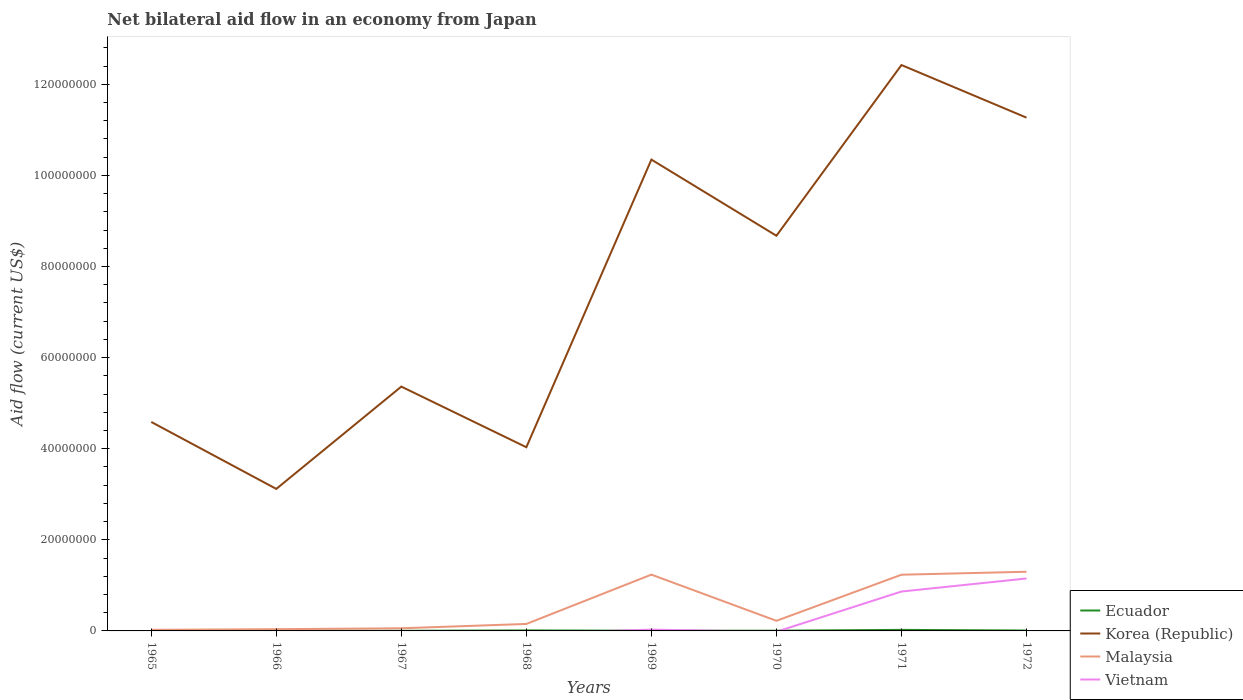How many different coloured lines are there?
Keep it short and to the point. 4. Does the line corresponding to Malaysia intersect with the line corresponding to Korea (Republic)?
Offer a very short reply. No. Is the number of lines equal to the number of legend labels?
Give a very brief answer. No. Across all years, what is the maximum net bilateral aid flow in Malaysia?
Offer a very short reply. 2.40e+05. What is the difference between the highest and the second highest net bilateral aid flow in Ecuador?
Offer a terse response. 2.10e+05. What is the difference between the highest and the lowest net bilateral aid flow in Ecuador?
Provide a succinct answer. 3. What is the difference between two consecutive major ticks on the Y-axis?
Ensure brevity in your answer.  2.00e+07. Are the values on the major ticks of Y-axis written in scientific E-notation?
Provide a succinct answer. No. Does the graph contain grids?
Your answer should be compact. No. How many legend labels are there?
Offer a very short reply. 4. How are the legend labels stacked?
Your response must be concise. Vertical. What is the title of the graph?
Make the answer very short. Net bilateral aid flow in an economy from Japan. What is the Aid flow (current US$) of Korea (Republic) in 1965?
Make the answer very short. 4.59e+07. What is the Aid flow (current US$) of Malaysia in 1965?
Provide a succinct answer. 2.40e+05. What is the Aid flow (current US$) in Ecuador in 1966?
Provide a succinct answer. 6.00e+04. What is the Aid flow (current US$) in Korea (Republic) in 1966?
Keep it short and to the point. 3.12e+07. What is the Aid flow (current US$) of Malaysia in 1966?
Offer a terse response. 3.80e+05. What is the Aid flow (current US$) of Korea (Republic) in 1967?
Your answer should be very brief. 5.36e+07. What is the Aid flow (current US$) in Malaysia in 1967?
Offer a very short reply. 5.80e+05. What is the Aid flow (current US$) of Korea (Republic) in 1968?
Offer a terse response. 4.03e+07. What is the Aid flow (current US$) in Malaysia in 1968?
Ensure brevity in your answer.  1.53e+06. What is the Aid flow (current US$) of Vietnam in 1968?
Your answer should be very brief. 0. What is the Aid flow (current US$) of Korea (Republic) in 1969?
Offer a very short reply. 1.03e+08. What is the Aid flow (current US$) of Malaysia in 1969?
Offer a very short reply. 1.24e+07. What is the Aid flow (current US$) of Vietnam in 1969?
Ensure brevity in your answer.  2.80e+05. What is the Aid flow (current US$) of Ecuador in 1970?
Give a very brief answer. 5.00e+04. What is the Aid flow (current US$) in Korea (Republic) in 1970?
Keep it short and to the point. 8.68e+07. What is the Aid flow (current US$) of Malaysia in 1970?
Ensure brevity in your answer.  2.22e+06. What is the Aid flow (current US$) of Vietnam in 1970?
Provide a short and direct response. 0. What is the Aid flow (current US$) of Ecuador in 1971?
Ensure brevity in your answer.  2.30e+05. What is the Aid flow (current US$) of Korea (Republic) in 1971?
Give a very brief answer. 1.24e+08. What is the Aid flow (current US$) of Malaysia in 1971?
Provide a succinct answer. 1.23e+07. What is the Aid flow (current US$) in Vietnam in 1971?
Offer a terse response. 8.65e+06. What is the Aid flow (current US$) in Ecuador in 1972?
Your answer should be compact. 9.00e+04. What is the Aid flow (current US$) of Korea (Republic) in 1972?
Make the answer very short. 1.13e+08. What is the Aid flow (current US$) in Malaysia in 1972?
Provide a short and direct response. 1.30e+07. What is the Aid flow (current US$) of Vietnam in 1972?
Give a very brief answer. 1.15e+07. Across all years, what is the maximum Aid flow (current US$) in Ecuador?
Give a very brief answer. 2.30e+05. Across all years, what is the maximum Aid flow (current US$) in Korea (Republic)?
Your response must be concise. 1.24e+08. Across all years, what is the maximum Aid flow (current US$) in Malaysia?
Provide a short and direct response. 1.30e+07. Across all years, what is the maximum Aid flow (current US$) in Vietnam?
Your answer should be compact. 1.15e+07. Across all years, what is the minimum Aid flow (current US$) in Korea (Republic)?
Your answer should be very brief. 3.12e+07. What is the total Aid flow (current US$) of Ecuador in the graph?
Your answer should be very brief. 6.30e+05. What is the total Aid flow (current US$) of Korea (Republic) in the graph?
Offer a terse response. 5.98e+08. What is the total Aid flow (current US$) of Malaysia in the graph?
Make the answer very short. 4.26e+07. What is the total Aid flow (current US$) in Vietnam in the graph?
Offer a terse response. 2.04e+07. What is the difference between the Aid flow (current US$) in Ecuador in 1965 and that in 1966?
Your answer should be compact. -4.00e+04. What is the difference between the Aid flow (current US$) of Korea (Republic) in 1965 and that in 1966?
Make the answer very short. 1.47e+07. What is the difference between the Aid flow (current US$) of Korea (Republic) in 1965 and that in 1967?
Make the answer very short. -7.76e+06. What is the difference between the Aid flow (current US$) in Malaysia in 1965 and that in 1967?
Give a very brief answer. -3.40e+05. What is the difference between the Aid flow (current US$) in Ecuador in 1965 and that in 1968?
Provide a succinct answer. -9.00e+04. What is the difference between the Aid flow (current US$) of Korea (Republic) in 1965 and that in 1968?
Your answer should be very brief. 5.55e+06. What is the difference between the Aid flow (current US$) of Malaysia in 1965 and that in 1968?
Offer a very short reply. -1.29e+06. What is the difference between the Aid flow (current US$) in Ecuador in 1965 and that in 1969?
Your answer should be very brief. -2.00e+04. What is the difference between the Aid flow (current US$) in Korea (Republic) in 1965 and that in 1969?
Offer a terse response. -5.76e+07. What is the difference between the Aid flow (current US$) in Malaysia in 1965 and that in 1969?
Your answer should be very brief. -1.21e+07. What is the difference between the Aid flow (current US$) of Ecuador in 1965 and that in 1970?
Give a very brief answer. -3.00e+04. What is the difference between the Aid flow (current US$) in Korea (Republic) in 1965 and that in 1970?
Offer a very short reply. -4.09e+07. What is the difference between the Aid flow (current US$) of Malaysia in 1965 and that in 1970?
Give a very brief answer. -1.98e+06. What is the difference between the Aid flow (current US$) in Ecuador in 1965 and that in 1971?
Ensure brevity in your answer.  -2.10e+05. What is the difference between the Aid flow (current US$) of Korea (Republic) in 1965 and that in 1971?
Your response must be concise. -7.84e+07. What is the difference between the Aid flow (current US$) in Malaysia in 1965 and that in 1971?
Your answer should be very brief. -1.21e+07. What is the difference between the Aid flow (current US$) of Korea (Republic) in 1965 and that in 1972?
Offer a very short reply. -6.68e+07. What is the difference between the Aid flow (current US$) of Malaysia in 1965 and that in 1972?
Offer a very short reply. -1.28e+07. What is the difference between the Aid flow (current US$) in Korea (Republic) in 1966 and that in 1967?
Give a very brief answer. -2.25e+07. What is the difference between the Aid flow (current US$) in Malaysia in 1966 and that in 1967?
Give a very brief answer. -2.00e+05. What is the difference between the Aid flow (current US$) of Ecuador in 1966 and that in 1968?
Provide a succinct answer. -5.00e+04. What is the difference between the Aid flow (current US$) of Korea (Republic) in 1966 and that in 1968?
Your answer should be compact. -9.15e+06. What is the difference between the Aid flow (current US$) of Malaysia in 1966 and that in 1968?
Keep it short and to the point. -1.15e+06. What is the difference between the Aid flow (current US$) of Korea (Republic) in 1966 and that in 1969?
Offer a very short reply. -7.23e+07. What is the difference between the Aid flow (current US$) of Malaysia in 1966 and that in 1969?
Give a very brief answer. -1.20e+07. What is the difference between the Aid flow (current US$) of Korea (Republic) in 1966 and that in 1970?
Your response must be concise. -5.56e+07. What is the difference between the Aid flow (current US$) of Malaysia in 1966 and that in 1970?
Your answer should be very brief. -1.84e+06. What is the difference between the Aid flow (current US$) of Ecuador in 1966 and that in 1971?
Your answer should be very brief. -1.70e+05. What is the difference between the Aid flow (current US$) in Korea (Republic) in 1966 and that in 1971?
Your response must be concise. -9.31e+07. What is the difference between the Aid flow (current US$) of Malaysia in 1966 and that in 1971?
Offer a terse response. -1.20e+07. What is the difference between the Aid flow (current US$) of Ecuador in 1966 and that in 1972?
Keep it short and to the point. -3.00e+04. What is the difference between the Aid flow (current US$) of Korea (Republic) in 1966 and that in 1972?
Make the answer very short. -8.15e+07. What is the difference between the Aid flow (current US$) in Malaysia in 1966 and that in 1972?
Offer a terse response. -1.26e+07. What is the difference between the Aid flow (current US$) of Ecuador in 1967 and that in 1968?
Make the answer very short. -8.00e+04. What is the difference between the Aid flow (current US$) in Korea (Republic) in 1967 and that in 1968?
Keep it short and to the point. 1.33e+07. What is the difference between the Aid flow (current US$) of Malaysia in 1967 and that in 1968?
Ensure brevity in your answer.  -9.50e+05. What is the difference between the Aid flow (current US$) in Korea (Republic) in 1967 and that in 1969?
Your response must be concise. -4.98e+07. What is the difference between the Aid flow (current US$) in Malaysia in 1967 and that in 1969?
Your answer should be very brief. -1.18e+07. What is the difference between the Aid flow (current US$) of Ecuador in 1967 and that in 1970?
Provide a short and direct response. -2.00e+04. What is the difference between the Aid flow (current US$) of Korea (Republic) in 1967 and that in 1970?
Make the answer very short. -3.31e+07. What is the difference between the Aid flow (current US$) in Malaysia in 1967 and that in 1970?
Provide a short and direct response. -1.64e+06. What is the difference between the Aid flow (current US$) of Ecuador in 1967 and that in 1971?
Your response must be concise. -2.00e+05. What is the difference between the Aid flow (current US$) in Korea (Republic) in 1967 and that in 1971?
Offer a terse response. -7.06e+07. What is the difference between the Aid flow (current US$) in Malaysia in 1967 and that in 1971?
Give a very brief answer. -1.18e+07. What is the difference between the Aid flow (current US$) of Korea (Republic) in 1967 and that in 1972?
Offer a terse response. -5.90e+07. What is the difference between the Aid flow (current US$) in Malaysia in 1967 and that in 1972?
Keep it short and to the point. -1.24e+07. What is the difference between the Aid flow (current US$) of Korea (Republic) in 1968 and that in 1969?
Keep it short and to the point. -6.32e+07. What is the difference between the Aid flow (current US$) of Malaysia in 1968 and that in 1969?
Offer a terse response. -1.08e+07. What is the difference between the Aid flow (current US$) of Ecuador in 1968 and that in 1970?
Your response must be concise. 6.00e+04. What is the difference between the Aid flow (current US$) in Korea (Republic) in 1968 and that in 1970?
Provide a succinct answer. -4.64e+07. What is the difference between the Aid flow (current US$) of Malaysia in 1968 and that in 1970?
Make the answer very short. -6.90e+05. What is the difference between the Aid flow (current US$) in Ecuador in 1968 and that in 1971?
Ensure brevity in your answer.  -1.20e+05. What is the difference between the Aid flow (current US$) of Korea (Republic) in 1968 and that in 1971?
Give a very brief answer. -8.39e+07. What is the difference between the Aid flow (current US$) in Malaysia in 1968 and that in 1971?
Give a very brief answer. -1.08e+07. What is the difference between the Aid flow (current US$) in Ecuador in 1968 and that in 1972?
Make the answer very short. 2.00e+04. What is the difference between the Aid flow (current US$) in Korea (Republic) in 1968 and that in 1972?
Make the answer very short. -7.24e+07. What is the difference between the Aid flow (current US$) of Malaysia in 1968 and that in 1972?
Provide a short and direct response. -1.15e+07. What is the difference between the Aid flow (current US$) in Ecuador in 1969 and that in 1970?
Offer a terse response. -10000. What is the difference between the Aid flow (current US$) in Korea (Republic) in 1969 and that in 1970?
Give a very brief answer. 1.67e+07. What is the difference between the Aid flow (current US$) of Malaysia in 1969 and that in 1970?
Your response must be concise. 1.01e+07. What is the difference between the Aid flow (current US$) in Korea (Republic) in 1969 and that in 1971?
Keep it short and to the point. -2.08e+07. What is the difference between the Aid flow (current US$) in Vietnam in 1969 and that in 1971?
Provide a succinct answer. -8.37e+06. What is the difference between the Aid flow (current US$) of Ecuador in 1969 and that in 1972?
Give a very brief answer. -5.00e+04. What is the difference between the Aid flow (current US$) in Korea (Republic) in 1969 and that in 1972?
Ensure brevity in your answer.  -9.21e+06. What is the difference between the Aid flow (current US$) of Malaysia in 1969 and that in 1972?
Offer a very short reply. -6.30e+05. What is the difference between the Aid flow (current US$) of Vietnam in 1969 and that in 1972?
Ensure brevity in your answer.  -1.12e+07. What is the difference between the Aid flow (current US$) of Korea (Republic) in 1970 and that in 1971?
Ensure brevity in your answer.  -3.75e+07. What is the difference between the Aid flow (current US$) of Malaysia in 1970 and that in 1971?
Your answer should be very brief. -1.01e+07. What is the difference between the Aid flow (current US$) of Korea (Republic) in 1970 and that in 1972?
Keep it short and to the point. -2.59e+07. What is the difference between the Aid flow (current US$) in Malaysia in 1970 and that in 1972?
Offer a terse response. -1.08e+07. What is the difference between the Aid flow (current US$) of Korea (Republic) in 1971 and that in 1972?
Keep it short and to the point. 1.16e+07. What is the difference between the Aid flow (current US$) of Malaysia in 1971 and that in 1972?
Provide a short and direct response. -6.50e+05. What is the difference between the Aid flow (current US$) of Vietnam in 1971 and that in 1972?
Provide a short and direct response. -2.86e+06. What is the difference between the Aid flow (current US$) of Ecuador in 1965 and the Aid flow (current US$) of Korea (Republic) in 1966?
Provide a short and direct response. -3.12e+07. What is the difference between the Aid flow (current US$) in Ecuador in 1965 and the Aid flow (current US$) in Malaysia in 1966?
Provide a short and direct response. -3.60e+05. What is the difference between the Aid flow (current US$) in Korea (Republic) in 1965 and the Aid flow (current US$) in Malaysia in 1966?
Ensure brevity in your answer.  4.55e+07. What is the difference between the Aid flow (current US$) in Ecuador in 1965 and the Aid flow (current US$) in Korea (Republic) in 1967?
Provide a succinct answer. -5.36e+07. What is the difference between the Aid flow (current US$) in Ecuador in 1965 and the Aid flow (current US$) in Malaysia in 1967?
Your response must be concise. -5.60e+05. What is the difference between the Aid flow (current US$) of Korea (Republic) in 1965 and the Aid flow (current US$) of Malaysia in 1967?
Keep it short and to the point. 4.53e+07. What is the difference between the Aid flow (current US$) in Ecuador in 1965 and the Aid flow (current US$) in Korea (Republic) in 1968?
Your answer should be compact. -4.03e+07. What is the difference between the Aid flow (current US$) of Ecuador in 1965 and the Aid flow (current US$) of Malaysia in 1968?
Provide a succinct answer. -1.51e+06. What is the difference between the Aid flow (current US$) of Korea (Republic) in 1965 and the Aid flow (current US$) of Malaysia in 1968?
Keep it short and to the point. 4.44e+07. What is the difference between the Aid flow (current US$) in Ecuador in 1965 and the Aid flow (current US$) in Korea (Republic) in 1969?
Provide a succinct answer. -1.03e+08. What is the difference between the Aid flow (current US$) in Ecuador in 1965 and the Aid flow (current US$) in Malaysia in 1969?
Offer a terse response. -1.23e+07. What is the difference between the Aid flow (current US$) in Korea (Republic) in 1965 and the Aid flow (current US$) in Malaysia in 1969?
Your answer should be very brief. 3.35e+07. What is the difference between the Aid flow (current US$) of Korea (Republic) in 1965 and the Aid flow (current US$) of Vietnam in 1969?
Ensure brevity in your answer.  4.56e+07. What is the difference between the Aid flow (current US$) of Malaysia in 1965 and the Aid flow (current US$) of Vietnam in 1969?
Your answer should be very brief. -4.00e+04. What is the difference between the Aid flow (current US$) in Ecuador in 1965 and the Aid flow (current US$) in Korea (Republic) in 1970?
Your response must be concise. -8.67e+07. What is the difference between the Aid flow (current US$) of Ecuador in 1965 and the Aid flow (current US$) of Malaysia in 1970?
Make the answer very short. -2.20e+06. What is the difference between the Aid flow (current US$) in Korea (Republic) in 1965 and the Aid flow (current US$) in Malaysia in 1970?
Provide a short and direct response. 4.37e+07. What is the difference between the Aid flow (current US$) in Ecuador in 1965 and the Aid flow (current US$) in Korea (Republic) in 1971?
Your answer should be compact. -1.24e+08. What is the difference between the Aid flow (current US$) in Ecuador in 1965 and the Aid flow (current US$) in Malaysia in 1971?
Make the answer very short. -1.23e+07. What is the difference between the Aid flow (current US$) in Ecuador in 1965 and the Aid flow (current US$) in Vietnam in 1971?
Provide a short and direct response. -8.63e+06. What is the difference between the Aid flow (current US$) of Korea (Republic) in 1965 and the Aid flow (current US$) of Malaysia in 1971?
Provide a succinct answer. 3.35e+07. What is the difference between the Aid flow (current US$) of Korea (Republic) in 1965 and the Aid flow (current US$) of Vietnam in 1971?
Ensure brevity in your answer.  3.72e+07. What is the difference between the Aid flow (current US$) of Malaysia in 1965 and the Aid flow (current US$) of Vietnam in 1971?
Your answer should be very brief. -8.41e+06. What is the difference between the Aid flow (current US$) of Ecuador in 1965 and the Aid flow (current US$) of Korea (Republic) in 1972?
Offer a very short reply. -1.13e+08. What is the difference between the Aid flow (current US$) of Ecuador in 1965 and the Aid flow (current US$) of Malaysia in 1972?
Ensure brevity in your answer.  -1.30e+07. What is the difference between the Aid flow (current US$) of Ecuador in 1965 and the Aid flow (current US$) of Vietnam in 1972?
Your response must be concise. -1.15e+07. What is the difference between the Aid flow (current US$) of Korea (Republic) in 1965 and the Aid flow (current US$) of Malaysia in 1972?
Your answer should be very brief. 3.29e+07. What is the difference between the Aid flow (current US$) in Korea (Republic) in 1965 and the Aid flow (current US$) in Vietnam in 1972?
Your response must be concise. 3.44e+07. What is the difference between the Aid flow (current US$) of Malaysia in 1965 and the Aid flow (current US$) of Vietnam in 1972?
Offer a terse response. -1.13e+07. What is the difference between the Aid flow (current US$) of Ecuador in 1966 and the Aid flow (current US$) of Korea (Republic) in 1967?
Your response must be concise. -5.36e+07. What is the difference between the Aid flow (current US$) of Ecuador in 1966 and the Aid flow (current US$) of Malaysia in 1967?
Keep it short and to the point. -5.20e+05. What is the difference between the Aid flow (current US$) of Korea (Republic) in 1966 and the Aid flow (current US$) of Malaysia in 1967?
Offer a very short reply. 3.06e+07. What is the difference between the Aid flow (current US$) of Ecuador in 1966 and the Aid flow (current US$) of Korea (Republic) in 1968?
Keep it short and to the point. -4.03e+07. What is the difference between the Aid flow (current US$) of Ecuador in 1966 and the Aid flow (current US$) of Malaysia in 1968?
Make the answer very short. -1.47e+06. What is the difference between the Aid flow (current US$) in Korea (Republic) in 1966 and the Aid flow (current US$) in Malaysia in 1968?
Make the answer very short. 2.96e+07. What is the difference between the Aid flow (current US$) of Ecuador in 1966 and the Aid flow (current US$) of Korea (Republic) in 1969?
Keep it short and to the point. -1.03e+08. What is the difference between the Aid flow (current US$) in Ecuador in 1966 and the Aid flow (current US$) in Malaysia in 1969?
Offer a very short reply. -1.23e+07. What is the difference between the Aid flow (current US$) in Korea (Republic) in 1966 and the Aid flow (current US$) in Malaysia in 1969?
Offer a terse response. 1.88e+07. What is the difference between the Aid flow (current US$) of Korea (Republic) in 1966 and the Aid flow (current US$) of Vietnam in 1969?
Make the answer very short. 3.09e+07. What is the difference between the Aid flow (current US$) in Ecuador in 1966 and the Aid flow (current US$) in Korea (Republic) in 1970?
Your response must be concise. -8.67e+07. What is the difference between the Aid flow (current US$) of Ecuador in 1966 and the Aid flow (current US$) of Malaysia in 1970?
Ensure brevity in your answer.  -2.16e+06. What is the difference between the Aid flow (current US$) in Korea (Republic) in 1966 and the Aid flow (current US$) in Malaysia in 1970?
Provide a succinct answer. 2.90e+07. What is the difference between the Aid flow (current US$) of Ecuador in 1966 and the Aid flow (current US$) of Korea (Republic) in 1971?
Ensure brevity in your answer.  -1.24e+08. What is the difference between the Aid flow (current US$) of Ecuador in 1966 and the Aid flow (current US$) of Malaysia in 1971?
Provide a short and direct response. -1.23e+07. What is the difference between the Aid flow (current US$) in Ecuador in 1966 and the Aid flow (current US$) in Vietnam in 1971?
Make the answer very short. -8.59e+06. What is the difference between the Aid flow (current US$) of Korea (Republic) in 1966 and the Aid flow (current US$) of Malaysia in 1971?
Your answer should be very brief. 1.88e+07. What is the difference between the Aid flow (current US$) in Korea (Republic) in 1966 and the Aid flow (current US$) in Vietnam in 1971?
Provide a short and direct response. 2.25e+07. What is the difference between the Aid flow (current US$) of Malaysia in 1966 and the Aid flow (current US$) of Vietnam in 1971?
Ensure brevity in your answer.  -8.27e+06. What is the difference between the Aid flow (current US$) of Ecuador in 1966 and the Aid flow (current US$) of Korea (Republic) in 1972?
Your answer should be very brief. -1.13e+08. What is the difference between the Aid flow (current US$) in Ecuador in 1966 and the Aid flow (current US$) in Malaysia in 1972?
Offer a very short reply. -1.29e+07. What is the difference between the Aid flow (current US$) of Ecuador in 1966 and the Aid flow (current US$) of Vietnam in 1972?
Offer a very short reply. -1.14e+07. What is the difference between the Aid flow (current US$) of Korea (Republic) in 1966 and the Aid flow (current US$) of Malaysia in 1972?
Your response must be concise. 1.82e+07. What is the difference between the Aid flow (current US$) of Korea (Republic) in 1966 and the Aid flow (current US$) of Vietnam in 1972?
Give a very brief answer. 1.97e+07. What is the difference between the Aid flow (current US$) of Malaysia in 1966 and the Aid flow (current US$) of Vietnam in 1972?
Offer a very short reply. -1.11e+07. What is the difference between the Aid flow (current US$) of Ecuador in 1967 and the Aid flow (current US$) of Korea (Republic) in 1968?
Provide a short and direct response. -4.03e+07. What is the difference between the Aid flow (current US$) of Ecuador in 1967 and the Aid flow (current US$) of Malaysia in 1968?
Provide a succinct answer. -1.50e+06. What is the difference between the Aid flow (current US$) in Korea (Republic) in 1967 and the Aid flow (current US$) in Malaysia in 1968?
Your answer should be very brief. 5.21e+07. What is the difference between the Aid flow (current US$) in Ecuador in 1967 and the Aid flow (current US$) in Korea (Republic) in 1969?
Give a very brief answer. -1.03e+08. What is the difference between the Aid flow (current US$) in Ecuador in 1967 and the Aid flow (current US$) in Malaysia in 1969?
Offer a terse response. -1.23e+07. What is the difference between the Aid flow (current US$) of Korea (Republic) in 1967 and the Aid flow (current US$) of Malaysia in 1969?
Make the answer very short. 4.13e+07. What is the difference between the Aid flow (current US$) in Korea (Republic) in 1967 and the Aid flow (current US$) in Vietnam in 1969?
Your response must be concise. 5.34e+07. What is the difference between the Aid flow (current US$) in Ecuador in 1967 and the Aid flow (current US$) in Korea (Republic) in 1970?
Your answer should be compact. -8.67e+07. What is the difference between the Aid flow (current US$) in Ecuador in 1967 and the Aid flow (current US$) in Malaysia in 1970?
Offer a very short reply. -2.19e+06. What is the difference between the Aid flow (current US$) of Korea (Republic) in 1967 and the Aid flow (current US$) of Malaysia in 1970?
Give a very brief answer. 5.14e+07. What is the difference between the Aid flow (current US$) of Ecuador in 1967 and the Aid flow (current US$) of Korea (Republic) in 1971?
Provide a succinct answer. -1.24e+08. What is the difference between the Aid flow (current US$) of Ecuador in 1967 and the Aid flow (current US$) of Malaysia in 1971?
Provide a succinct answer. -1.23e+07. What is the difference between the Aid flow (current US$) of Ecuador in 1967 and the Aid flow (current US$) of Vietnam in 1971?
Your answer should be compact. -8.62e+06. What is the difference between the Aid flow (current US$) of Korea (Republic) in 1967 and the Aid flow (current US$) of Malaysia in 1971?
Offer a terse response. 4.13e+07. What is the difference between the Aid flow (current US$) in Korea (Republic) in 1967 and the Aid flow (current US$) in Vietnam in 1971?
Your answer should be compact. 4.50e+07. What is the difference between the Aid flow (current US$) in Malaysia in 1967 and the Aid flow (current US$) in Vietnam in 1971?
Provide a succinct answer. -8.07e+06. What is the difference between the Aid flow (current US$) of Ecuador in 1967 and the Aid flow (current US$) of Korea (Republic) in 1972?
Your answer should be compact. -1.13e+08. What is the difference between the Aid flow (current US$) of Ecuador in 1967 and the Aid flow (current US$) of Malaysia in 1972?
Keep it short and to the point. -1.30e+07. What is the difference between the Aid flow (current US$) in Ecuador in 1967 and the Aid flow (current US$) in Vietnam in 1972?
Keep it short and to the point. -1.15e+07. What is the difference between the Aid flow (current US$) of Korea (Republic) in 1967 and the Aid flow (current US$) of Malaysia in 1972?
Your response must be concise. 4.06e+07. What is the difference between the Aid flow (current US$) of Korea (Republic) in 1967 and the Aid flow (current US$) of Vietnam in 1972?
Your answer should be compact. 4.21e+07. What is the difference between the Aid flow (current US$) of Malaysia in 1967 and the Aid flow (current US$) of Vietnam in 1972?
Give a very brief answer. -1.09e+07. What is the difference between the Aid flow (current US$) in Ecuador in 1968 and the Aid flow (current US$) in Korea (Republic) in 1969?
Give a very brief answer. -1.03e+08. What is the difference between the Aid flow (current US$) of Ecuador in 1968 and the Aid flow (current US$) of Malaysia in 1969?
Ensure brevity in your answer.  -1.22e+07. What is the difference between the Aid flow (current US$) of Korea (Republic) in 1968 and the Aid flow (current US$) of Malaysia in 1969?
Your answer should be compact. 2.80e+07. What is the difference between the Aid flow (current US$) in Korea (Republic) in 1968 and the Aid flow (current US$) in Vietnam in 1969?
Offer a very short reply. 4.00e+07. What is the difference between the Aid flow (current US$) in Malaysia in 1968 and the Aid flow (current US$) in Vietnam in 1969?
Your response must be concise. 1.25e+06. What is the difference between the Aid flow (current US$) in Ecuador in 1968 and the Aid flow (current US$) in Korea (Republic) in 1970?
Give a very brief answer. -8.66e+07. What is the difference between the Aid flow (current US$) in Ecuador in 1968 and the Aid flow (current US$) in Malaysia in 1970?
Offer a terse response. -2.11e+06. What is the difference between the Aid flow (current US$) in Korea (Republic) in 1968 and the Aid flow (current US$) in Malaysia in 1970?
Make the answer very short. 3.81e+07. What is the difference between the Aid flow (current US$) in Ecuador in 1968 and the Aid flow (current US$) in Korea (Republic) in 1971?
Keep it short and to the point. -1.24e+08. What is the difference between the Aid flow (current US$) in Ecuador in 1968 and the Aid flow (current US$) in Malaysia in 1971?
Your response must be concise. -1.22e+07. What is the difference between the Aid flow (current US$) in Ecuador in 1968 and the Aid flow (current US$) in Vietnam in 1971?
Keep it short and to the point. -8.54e+06. What is the difference between the Aid flow (current US$) of Korea (Republic) in 1968 and the Aid flow (current US$) of Malaysia in 1971?
Offer a terse response. 2.80e+07. What is the difference between the Aid flow (current US$) in Korea (Republic) in 1968 and the Aid flow (current US$) in Vietnam in 1971?
Give a very brief answer. 3.17e+07. What is the difference between the Aid flow (current US$) of Malaysia in 1968 and the Aid flow (current US$) of Vietnam in 1971?
Keep it short and to the point. -7.12e+06. What is the difference between the Aid flow (current US$) of Ecuador in 1968 and the Aid flow (current US$) of Korea (Republic) in 1972?
Give a very brief answer. -1.13e+08. What is the difference between the Aid flow (current US$) of Ecuador in 1968 and the Aid flow (current US$) of Malaysia in 1972?
Your answer should be very brief. -1.29e+07. What is the difference between the Aid flow (current US$) in Ecuador in 1968 and the Aid flow (current US$) in Vietnam in 1972?
Make the answer very short. -1.14e+07. What is the difference between the Aid flow (current US$) of Korea (Republic) in 1968 and the Aid flow (current US$) of Malaysia in 1972?
Your answer should be compact. 2.73e+07. What is the difference between the Aid flow (current US$) of Korea (Republic) in 1968 and the Aid flow (current US$) of Vietnam in 1972?
Make the answer very short. 2.88e+07. What is the difference between the Aid flow (current US$) of Malaysia in 1968 and the Aid flow (current US$) of Vietnam in 1972?
Your response must be concise. -9.98e+06. What is the difference between the Aid flow (current US$) of Ecuador in 1969 and the Aid flow (current US$) of Korea (Republic) in 1970?
Offer a very short reply. -8.67e+07. What is the difference between the Aid flow (current US$) of Ecuador in 1969 and the Aid flow (current US$) of Malaysia in 1970?
Give a very brief answer. -2.18e+06. What is the difference between the Aid flow (current US$) in Korea (Republic) in 1969 and the Aid flow (current US$) in Malaysia in 1970?
Your response must be concise. 1.01e+08. What is the difference between the Aid flow (current US$) in Ecuador in 1969 and the Aid flow (current US$) in Korea (Republic) in 1971?
Ensure brevity in your answer.  -1.24e+08. What is the difference between the Aid flow (current US$) in Ecuador in 1969 and the Aid flow (current US$) in Malaysia in 1971?
Your answer should be very brief. -1.23e+07. What is the difference between the Aid flow (current US$) of Ecuador in 1969 and the Aid flow (current US$) of Vietnam in 1971?
Keep it short and to the point. -8.61e+06. What is the difference between the Aid flow (current US$) of Korea (Republic) in 1969 and the Aid flow (current US$) of Malaysia in 1971?
Make the answer very short. 9.11e+07. What is the difference between the Aid flow (current US$) in Korea (Republic) in 1969 and the Aid flow (current US$) in Vietnam in 1971?
Make the answer very short. 9.48e+07. What is the difference between the Aid flow (current US$) in Malaysia in 1969 and the Aid flow (current US$) in Vietnam in 1971?
Your response must be concise. 3.71e+06. What is the difference between the Aid flow (current US$) of Ecuador in 1969 and the Aid flow (current US$) of Korea (Republic) in 1972?
Offer a terse response. -1.13e+08. What is the difference between the Aid flow (current US$) of Ecuador in 1969 and the Aid flow (current US$) of Malaysia in 1972?
Your response must be concise. -1.30e+07. What is the difference between the Aid flow (current US$) in Ecuador in 1969 and the Aid flow (current US$) in Vietnam in 1972?
Offer a terse response. -1.15e+07. What is the difference between the Aid flow (current US$) of Korea (Republic) in 1969 and the Aid flow (current US$) of Malaysia in 1972?
Make the answer very short. 9.05e+07. What is the difference between the Aid flow (current US$) in Korea (Republic) in 1969 and the Aid flow (current US$) in Vietnam in 1972?
Make the answer very short. 9.20e+07. What is the difference between the Aid flow (current US$) of Malaysia in 1969 and the Aid flow (current US$) of Vietnam in 1972?
Give a very brief answer. 8.50e+05. What is the difference between the Aid flow (current US$) in Ecuador in 1970 and the Aid flow (current US$) in Korea (Republic) in 1971?
Offer a terse response. -1.24e+08. What is the difference between the Aid flow (current US$) of Ecuador in 1970 and the Aid flow (current US$) of Malaysia in 1971?
Make the answer very short. -1.23e+07. What is the difference between the Aid flow (current US$) in Ecuador in 1970 and the Aid flow (current US$) in Vietnam in 1971?
Offer a very short reply. -8.60e+06. What is the difference between the Aid flow (current US$) in Korea (Republic) in 1970 and the Aid flow (current US$) in Malaysia in 1971?
Ensure brevity in your answer.  7.44e+07. What is the difference between the Aid flow (current US$) of Korea (Republic) in 1970 and the Aid flow (current US$) of Vietnam in 1971?
Your answer should be very brief. 7.81e+07. What is the difference between the Aid flow (current US$) of Malaysia in 1970 and the Aid flow (current US$) of Vietnam in 1971?
Your answer should be compact. -6.43e+06. What is the difference between the Aid flow (current US$) in Ecuador in 1970 and the Aid flow (current US$) in Korea (Republic) in 1972?
Your response must be concise. -1.13e+08. What is the difference between the Aid flow (current US$) in Ecuador in 1970 and the Aid flow (current US$) in Malaysia in 1972?
Provide a short and direct response. -1.29e+07. What is the difference between the Aid flow (current US$) in Ecuador in 1970 and the Aid flow (current US$) in Vietnam in 1972?
Keep it short and to the point. -1.15e+07. What is the difference between the Aid flow (current US$) in Korea (Republic) in 1970 and the Aid flow (current US$) in Malaysia in 1972?
Provide a short and direct response. 7.38e+07. What is the difference between the Aid flow (current US$) of Korea (Republic) in 1970 and the Aid flow (current US$) of Vietnam in 1972?
Your response must be concise. 7.52e+07. What is the difference between the Aid flow (current US$) of Malaysia in 1970 and the Aid flow (current US$) of Vietnam in 1972?
Provide a succinct answer. -9.29e+06. What is the difference between the Aid flow (current US$) in Ecuador in 1971 and the Aid flow (current US$) in Korea (Republic) in 1972?
Your answer should be very brief. -1.12e+08. What is the difference between the Aid flow (current US$) in Ecuador in 1971 and the Aid flow (current US$) in Malaysia in 1972?
Make the answer very short. -1.28e+07. What is the difference between the Aid flow (current US$) in Ecuador in 1971 and the Aid flow (current US$) in Vietnam in 1972?
Keep it short and to the point. -1.13e+07. What is the difference between the Aid flow (current US$) of Korea (Republic) in 1971 and the Aid flow (current US$) of Malaysia in 1972?
Your answer should be compact. 1.11e+08. What is the difference between the Aid flow (current US$) in Korea (Republic) in 1971 and the Aid flow (current US$) in Vietnam in 1972?
Provide a short and direct response. 1.13e+08. What is the difference between the Aid flow (current US$) in Malaysia in 1971 and the Aid flow (current US$) in Vietnam in 1972?
Keep it short and to the point. 8.30e+05. What is the average Aid flow (current US$) of Ecuador per year?
Offer a very short reply. 7.88e+04. What is the average Aid flow (current US$) of Korea (Republic) per year?
Keep it short and to the point. 7.48e+07. What is the average Aid flow (current US$) in Malaysia per year?
Your answer should be very brief. 5.33e+06. What is the average Aid flow (current US$) in Vietnam per year?
Provide a succinct answer. 2.56e+06. In the year 1965, what is the difference between the Aid flow (current US$) in Ecuador and Aid flow (current US$) in Korea (Republic)?
Ensure brevity in your answer.  -4.59e+07. In the year 1965, what is the difference between the Aid flow (current US$) of Korea (Republic) and Aid flow (current US$) of Malaysia?
Make the answer very short. 4.56e+07. In the year 1966, what is the difference between the Aid flow (current US$) of Ecuador and Aid flow (current US$) of Korea (Republic)?
Provide a short and direct response. -3.11e+07. In the year 1966, what is the difference between the Aid flow (current US$) in Ecuador and Aid flow (current US$) in Malaysia?
Make the answer very short. -3.20e+05. In the year 1966, what is the difference between the Aid flow (current US$) of Korea (Republic) and Aid flow (current US$) of Malaysia?
Give a very brief answer. 3.08e+07. In the year 1967, what is the difference between the Aid flow (current US$) of Ecuador and Aid flow (current US$) of Korea (Republic)?
Give a very brief answer. -5.36e+07. In the year 1967, what is the difference between the Aid flow (current US$) in Ecuador and Aid flow (current US$) in Malaysia?
Make the answer very short. -5.50e+05. In the year 1967, what is the difference between the Aid flow (current US$) in Korea (Republic) and Aid flow (current US$) in Malaysia?
Give a very brief answer. 5.31e+07. In the year 1968, what is the difference between the Aid flow (current US$) in Ecuador and Aid flow (current US$) in Korea (Republic)?
Your answer should be very brief. -4.02e+07. In the year 1968, what is the difference between the Aid flow (current US$) of Ecuador and Aid flow (current US$) of Malaysia?
Provide a succinct answer. -1.42e+06. In the year 1968, what is the difference between the Aid flow (current US$) of Korea (Republic) and Aid flow (current US$) of Malaysia?
Make the answer very short. 3.88e+07. In the year 1969, what is the difference between the Aid flow (current US$) of Ecuador and Aid flow (current US$) of Korea (Republic)?
Your answer should be compact. -1.03e+08. In the year 1969, what is the difference between the Aid flow (current US$) in Ecuador and Aid flow (current US$) in Malaysia?
Offer a terse response. -1.23e+07. In the year 1969, what is the difference between the Aid flow (current US$) of Ecuador and Aid flow (current US$) of Vietnam?
Offer a terse response. -2.40e+05. In the year 1969, what is the difference between the Aid flow (current US$) in Korea (Republic) and Aid flow (current US$) in Malaysia?
Offer a terse response. 9.11e+07. In the year 1969, what is the difference between the Aid flow (current US$) of Korea (Republic) and Aid flow (current US$) of Vietnam?
Ensure brevity in your answer.  1.03e+08. In the year 1969, what is the difference between the Aid flow (current US$) in Malaysia and Aid flow (current US$) in Vietnam?
Offer a very short reply. 1.21e+07. In the year 1970, what is the difference between the Aid flow (current US$) of Ecuador and Aid flow (current US$) of Korea (Republic)?
Your answer should be very brief. -8.67e+07. In the year 1970, what is the difference between the Aid flow (current US$) in Ecuador and Aid flow (current US$) in Malaysia?
Ensure brevity in your answer.  -2.17e+06. In the year 1970, what is the difference between the Aid flow (current US$) of Korea (Republic) and Aid flow (current US$) of Malaysia?
Offer a very short reply. 8.45e+07. In the year 1971, what is the difference between the Aid flow (current US$) in Ecuador and Aid flow (current US$) in Korea (Republic)?
Your answer should be compact. -1.24e+08. In the year 1971, what is the difference between the Aid flow (current US$) of Ecuador and Aid flow (current US$) of Malaysia?
Offer a terse response. -1.21e+07. In the year 1971, what is the difference between the Aid flow (current US$) of Ecuador and Aid flow (current US$) of Vietnam?
Keep it short and to the point. -8.42e+06. In the year 1971, what is the difference between the Aid flow (current US$) of Korea (Republic) and Aid flow (current US$) of Malaysia?
Keep it short and to the point. 1.12e+08. In the year 1971, what is the difference between the Aid flow (current US$) in Korea (Republic) and Aid flow (current US$) in Vietnam?
Offer a terse response. 1.16e+08. In the year 1971, what is the difference between the Aid flow (current US$) in Malaysia and Aid flow (current US$) in Vietnam?
Give a very brief answer. 3.69e+06. In the year 1972, what is the difference between the Aid flow (current US$) in Ecuador and Aid flow (current US$) in Korea (Republic)?
Ensure brevity in your answer.  -1.13e+08. In the year 1972, what is the difference between the Aid flow (current US$) of Ecuador and Aid flow (current US$) of Malaysia?
Give a very brief answer. -1.29e+07. In the year 1972, what is the difference between the Aid flow (current US$) in Ecuador and Aid flow (current US$) in Vietnam?
Provide a succinct answer. -1.14e+07. In the year 1972, what is the difference between the Aid flow (current US$) of Korea (Republic) and Aid flow (current US$) of Malaysia?
Your answer should be compact. 9.97e+07. In the year 1972, what is the difference between the Aid flow (current US$) of Korea (Republic) and Aid flow (current US$) of Vietnam?
Ensure brevity in your answer.  1.01e+08. In the year 1972, what is the difference between the Aid flow (current US$) in Malaysia and Aid flow (current US$) in Vietnam?
Ensure brevity in your answer.  1.48e+06. What is the ratio of the Aid flow (current US$) of Korea (Republic) in 1965 to that in 1966?
Offer a terse response. 1.47. What is the ratio of the Aid flow (current US$) of Malaysia in 1965 to that in 1966?
Your response must be concise. 0.63. What is the ratio of the Aid flow (current US$) in Korea (Republic) in 1965 to that in 1967?
Keep it short and to the point. 0.86. What is the ratio of the Aid flow (current US$) in Malaysia in 1965 to that in 1967?
Make the answer very short. 0.41. What is the ratio of the Aid flow (current US$) of Ecuador in 1965 to that in 1968?
Your response must be concise. 0.18. What is the ratio of the Aid flow (current US$) of Korea (Republic) in 1965 to that in 1968?
Your answer should be very brief. 1.14. What is the ratio of the Aid flow (current US$) in Malaysia in 1965 to that in 1968?
Offer a very short reply. 0.16. What is the ratio of the Aid flow (current US$) in Korea (Republic) in 1965 to that in 1969?
Ensure brevity in your answer.  0.44. What is the ratio of the Aid flow (current US$) of Malaysia in 1965 to that in 1969?
Offer a very short reply. 0.02. What is the ratio of the Aid flow (current US$) in Ecuador in 1965 to that in 1970?
Offer a terse response. 0.4. What is the ratio of the Aid flow (current US$) of Korea (Republic) in 1965 to that in 1970?
Your answer should be compact. 0.53. What is the ratio of the Aid flow (current US$) in Malaysia in 1965 to that in 1970?
Ensure brevity in your answer.  0.11. What is the ratio of the Aid flow (current US$) of Ecuador in 1965 to that in 1971?
Keep it short and to the point. 0.09. What is the ratio of the Aid flow (current US$) of Korea (Republic) in 1965 to that in 1971?
Provide a succinct answer. 0.37. What is the ratio of the Aid flow (current US$) of Malaysia in 1965 to that in 1971?
Offer a terse response. 0.02. What is the ratio of the Aid flow (current US$) in Ecuador in 1965 to that in 1972?
Offer a terse response. 0.22. What is the ratio of the Aid flow (current US$) in Korea (Republic) in 1965 to that in 1972?
Make the answer very short. 0.41. What is the ratio of the Aid flow (current US$) of Malaysia in 1965 to that in 1972?
Ensure brevity in your answer.  0.02. What is the ratio of the Aid flow (current US$) in Ecuador in 1966 to that in 1967?
Offer a very short reply. 2. What is the ratio of the Aid flow (current US$) of Korea (Republic) in 1966 to that in 1967?
Offer a terse response. 0.58. What is the ratio of the Aid flow (current US$) of Malaysia in 1966 to that in 1967?
Keep it short and to the point. 0.66. What is the ratio of the Aid flow (current US$) in Ecuador in 1966 to that in 1968?
Offer a very short reply. 0.55. What is the ratio of the Aid flow (current US$) of Korea (Republic) in 1966 to that in 1968?
Offer a very short reply. 0.77. What is the ratio of the Aid flow (current US$) in Malaysia in 1966 to that in 1968?
Offer a very short reply. 0.25. What is the ratio of the Aid flow (current US$) in Ecuador in 1966 to that in 1969?
Give a very brief answer. 1.5. What is the ratio of the Aid flow (current US$) in Korea (Republic) in 1966 to that in 1969?
Your answer should be very brief. 0.3. What is the ratio of the Aid flow (current US$) of Malaysia in 1966 to that in 1969?
Give a very brief answer. 0.03. What is the ratio of the Aid flow (current US$) in Ecuador in 1966 to that in 1970?
Your response must be concise. 1.2. What is the ratio of the Aid flow (current US$) in Korea (Republic) in 1966 to that in 1970?
Keep it short and to the point. 0.36. What is the ratio of the Aid flow (current US$) in Malaysia in 1966 to that in 1970?
Your answer should be compact. 0.17. What is the ratio of the Aid flow (current US$) in Ecuador in 1966 to that in 1971?
Your answer should be very brief. 0.26. What is the ratio of the Aid flow (current US$) of Korea (Republic) in 1966 to that in 1971?
Make the answer very short. 0.25. What is the ratio of the Aid flow (current US$) in Malaysia in 1966 to that in 1971?
Provide a short and direct response. 0.03. What is the ratio of the Aid flow (current US$) in Ecuador in 1966 to that in 1972?
Give a very brief answer. 0.67. What is the ratio of the Aid flow (current US$) in Korea (Republic) in 1966 to that in 1972?
Your response must be concise. 0.28. What is the ratio of the Aid flow (current US$) of Malaysia in 1966 to that in 1972?
Your answer should be compact. 0.03. What is the ratio of the Aid flow (current US$) in Ecuador in 1967 to that in 1968?
Keep it short and to the point. 0.27. What is the ratio of the Aid flow (current US$) in Korea (Republic) in 1967 to that in 1968?
Your answer should be very brief. 1.33. What is the ratio of the Aid flow (current US$) of Malaysia in 1967 to that in 1968?
Offer a terse response. 0.38. What is the ratio of the Aid flow (current US$) in Ecuador in 1967 to that in 1969?
Your response must be concise. 0.75. What is the ratio of the Aid flow (current US$) in Korea (Republic) in 1967 to that in 1969?
Your answer should be very brief. 0.52. What is the ratio of the Aid flow (current US$) in Malaysia in 1967 to that in 1969?
Offer a terse response. 0.05. What is the ratio of the Aid flow (current US$) in Ecuador in 1967 to that in 1970?
Make the answer very short. 0.6. What is the ratio of the Aid flow (current US$) in Korea (Republic) in 1967 to that in 1970?
Offer a very short reply. 0.62. What is the ratio of the Aid flow (current US$) in Malaysia in 1967 to that in 1970?
Your response must be concise. 0.26. What is the ratio of the Aid flow (current US$) in Ecuador in 1967 to that in 1971?
Make the answer very short. 0.13. What is the ratio of the Aid flow (current US$) of Korea (Republic) in 1967 to that in 1971?
Provide a succinct answer. 0.43. What is the ratio of the Aid flow (current US$) in Malaysia in 1967 to that in 1971?
Your answer should be compact. 0.05. What is the ratio of the Aid flow (current US$) of Ecuador in 1967 to that in 1972?
Keep it short and to the point. 0.33. What is the ratio of the Aid flow (current US$) of Korea (Republic) in 1967 to that in 1972?
Your response must be concise. 0.48. What is the ratio of the Aid flow (current US$) in Malaysia in 1967 to that in 1972?
Provide a succinct answer. 0.04. What is the ratio of the Aid flow (current US$) in Ecuador in 1968 to that in 1969?
Make the answer very short. 2.75. What is the ratio of the Aid flow (current US$) of Korea (Republic) in 1968 to that in 1969?
Provide a short and direct response. 0.39. What is the ratio of the Aid flow (current US$) in Malaysia in 1968 to that in 1969?
Your answer should be very brief. 0.12. What is the ratio of the Aid flow (current US$) of Korea (Republic) in 1968 to that in 1970?
Your answer should be very brief. 0.46. What is the ratio of the Aid flow (current US$) in Malaysia in 1968 to that in 1970?
Offer a very short reply. 0.69. What is the ratio of the Aid flow (current US$) in Ecuador in 1968 to that in 1971?
Offer a terse response. 0.48. What is the ratio of the Aid flow (current US$) in Korea (Republic) in 1968 to that in 1971?
Provide a short and direct response. 0.32. What is the ratio of the Aid flow (current US$) of Malaysia in 1968 to that in 1971?
Your answer should be compact. 0.12. What is the ratio of the Aid flow (current US$) in Ecuador in 1968 to that in 1972?
Your answer should be very brief. 1.22. What is the ratio of the Aid flow (current US$) of Korea (Republic) in 1968 to that in 1972?
Offer a very short reply. 0.36. What is the ratio of the Aid flow (current US$) of Malaysia in 1968 to that in 1972?
Make the answer very short. 0.12. What is the ratio of the Aid flow (current US$) in Ecuador in 1969 to that in 1970?
Offer a very short reply. 0.8. What is the ratio of the Aid flow (current US$) in Korea (Republic) in 1969 to that in 1970?
Your response must be concise. 1.19. What is the ratio of the Aid flow (current US$) in Malaysia in 1969 to that in 1970?
Provide a short and direct response. 5.57. What is the ratio of the Aid flow (current US$) of Ecuador in 1969 to that in 1971?
Make the answer very short. 0.17. What is the ratio of the Aid flow (current US$) of Korea (Republic) in 1969 to that in 1971?
Your response must be concise. 0.83. What is the ratio of the Aid flow (current US$) of Vietnam in 1969 to that in 1971?
Offer a terse response. 0.03. What is the ratio of the Aid flow (current US$) of Ecuador in 1969 to that in 1972?
Your answer should be very brief. 0.44. What is the ratio of the Aid flow (current US$) of Korea (Republic) in 1969 to that in 1972?
Give a very brief answer. 0.92. What is the ratio of the Aid flow (current US$) in Malaysia in 1969 to that in 1972?
Give a very brief answer. 0.95. What is the ratio of the Aid flow (current US$) of Vietnam in 1969 to that in 1972?
Offer a terse response. 0.02. What is the ratio of the Aid flow (current US$) of Ecuador in 1970 to that in 1971?
Offer a terse response. 0.22. What is the ratio of the Aid flow (current US$) in Korea (Republic) in 1970 to that in 1971?
Provide a short and direct response. 0.7. What is the ratio of the Aid flow (current US$) of Malaysia in 1970 to that in 1971?
Ensure brevity in your answer.  0.18. What is the ratio of the Aid flow (current US$) in Ecuador in 1970 to that in 1972?
Provide a short and direct response. 0.56. What is the ratio of the Aid flow (current US$) of Korea (Republic) in 1970 to that in 1972?
Your answer should be very brief. 0.77. What is the ratio of the Aid flow (current US$) of Malaysia in 1970 to that in 1972?
Offer a very short reply. 0.17. What is the ratio of the Aid flow (current US$) in Ecuador in 1971 to that in 1972?
Your response must be concise. 2.56. What is the ratio of the Aid flow (current US$) of Korea (Republic) in 1971 to that in 1972?
Your response must be concise. 1.1. What is the ratio of the Aid flow (current US$) of Vietnam in 1971 to that in 1972?
Offer a very short reply. 0.75. What is the difference between the highest and the second highest Aid flow (current US$) of Korea (Republic)?
Offer a terse response. 1.16e+07. What is the difference between the highest and the second highest Aid flow (current US$) in Malaysia?
Offer a very short reply. 6.30e+05. What is the difference between the highest and the second highest Aid flow (current US$) of Vietnam?
Provide a short and direct response. 2.86e+06. What is the difference between the highest and the lowest Aid flow (current US$) in Korea (Republic)?
Provide a succinct answer. 9.31e+07. What is the difference between the highest and the lowest Aid flow (current US$) of Malaysia?
Keep it short and to the point. 1.28e+07. What is the difference between the highest and the lowest Aid flow (current US$) of Vietnam?
Make the answer very short. 1.15e+07. 